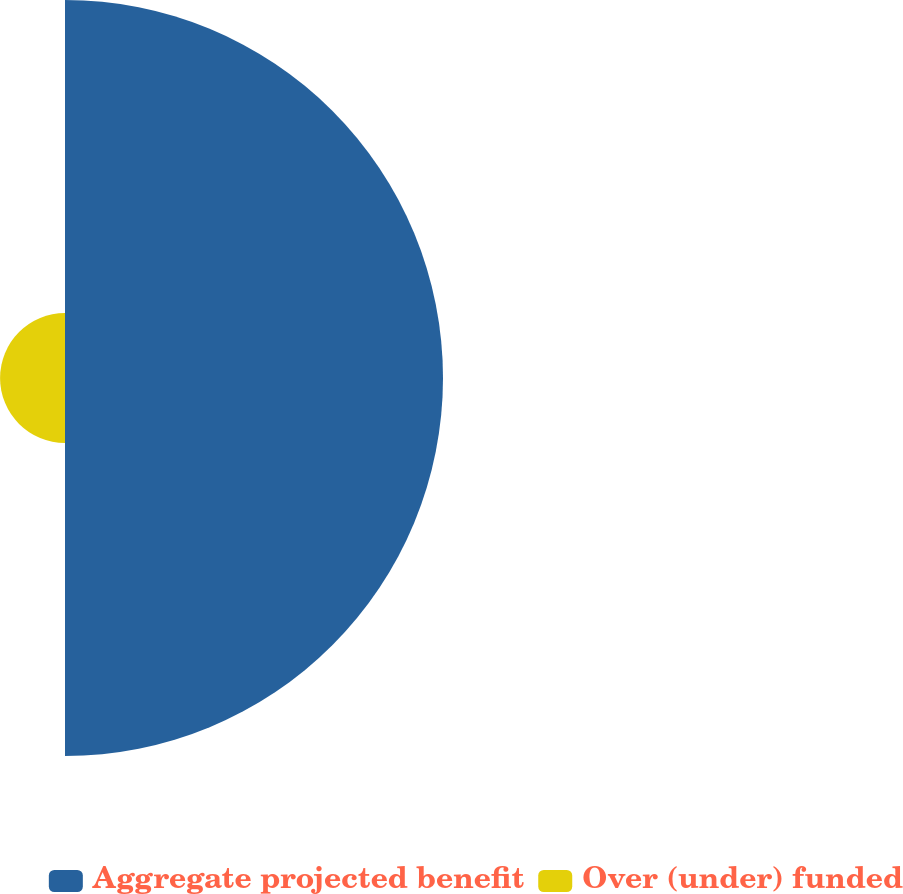<chart> <loc_0><loc_0><loc_500><loc_500><pie_chart><fcel>Aggregate projected benefit<fcel>Over (under) funded<nl><fcel>85.34%<fcel>14.66%<nl></chart> 